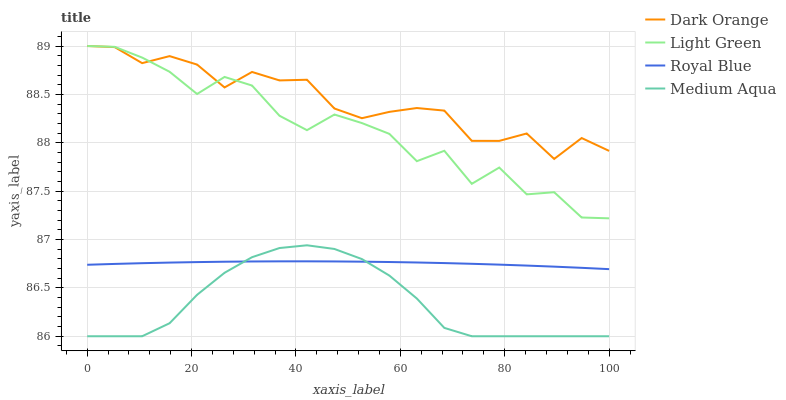Does Medium Aqua have the minimum area under the curve?
Answer yes or no. Yes. Does Dark Orange have the maximum area under the curve?
Answer yes or no. Yes. Does Light Green have the minimum area under the curve?
Answer yes or no. No. Does Light Green have the maximum area under the curve?
Answer yes or no. No. Is Royal Blue the smoothest?
Answer yes or no. Yes. Is Light Green the roughest?
Answer yes or no. Yes. Is Medium Aqua the smoothest?
Answer yes or no. No. Is Medium Aqua the roughest?
Answer yes or no. No. Does Light Green have the lowest value?
Answer yes or no. No. Does Light Green have the highest value?
Answer yes or no. Yes. Does Medium Aqua have the highest value?
Answer yes or no. No. Is Medium Aqua less than Dark Orange?
Answer yes or no. Yes. Is Light Green greater than Medium Aqua?
Answer yes or no. Yes. Does Royal Blue intersect Medium Aqua?
Answer yes or no. Yes. Is Royal Blue less than Medium Aqua?
Answer yes or no. No. Is Royal Blue greater than Medium Aqua?
Answer yes or no. No. Does Medium Aqua intersect Dark Orange?
Answer yes or no. No. 